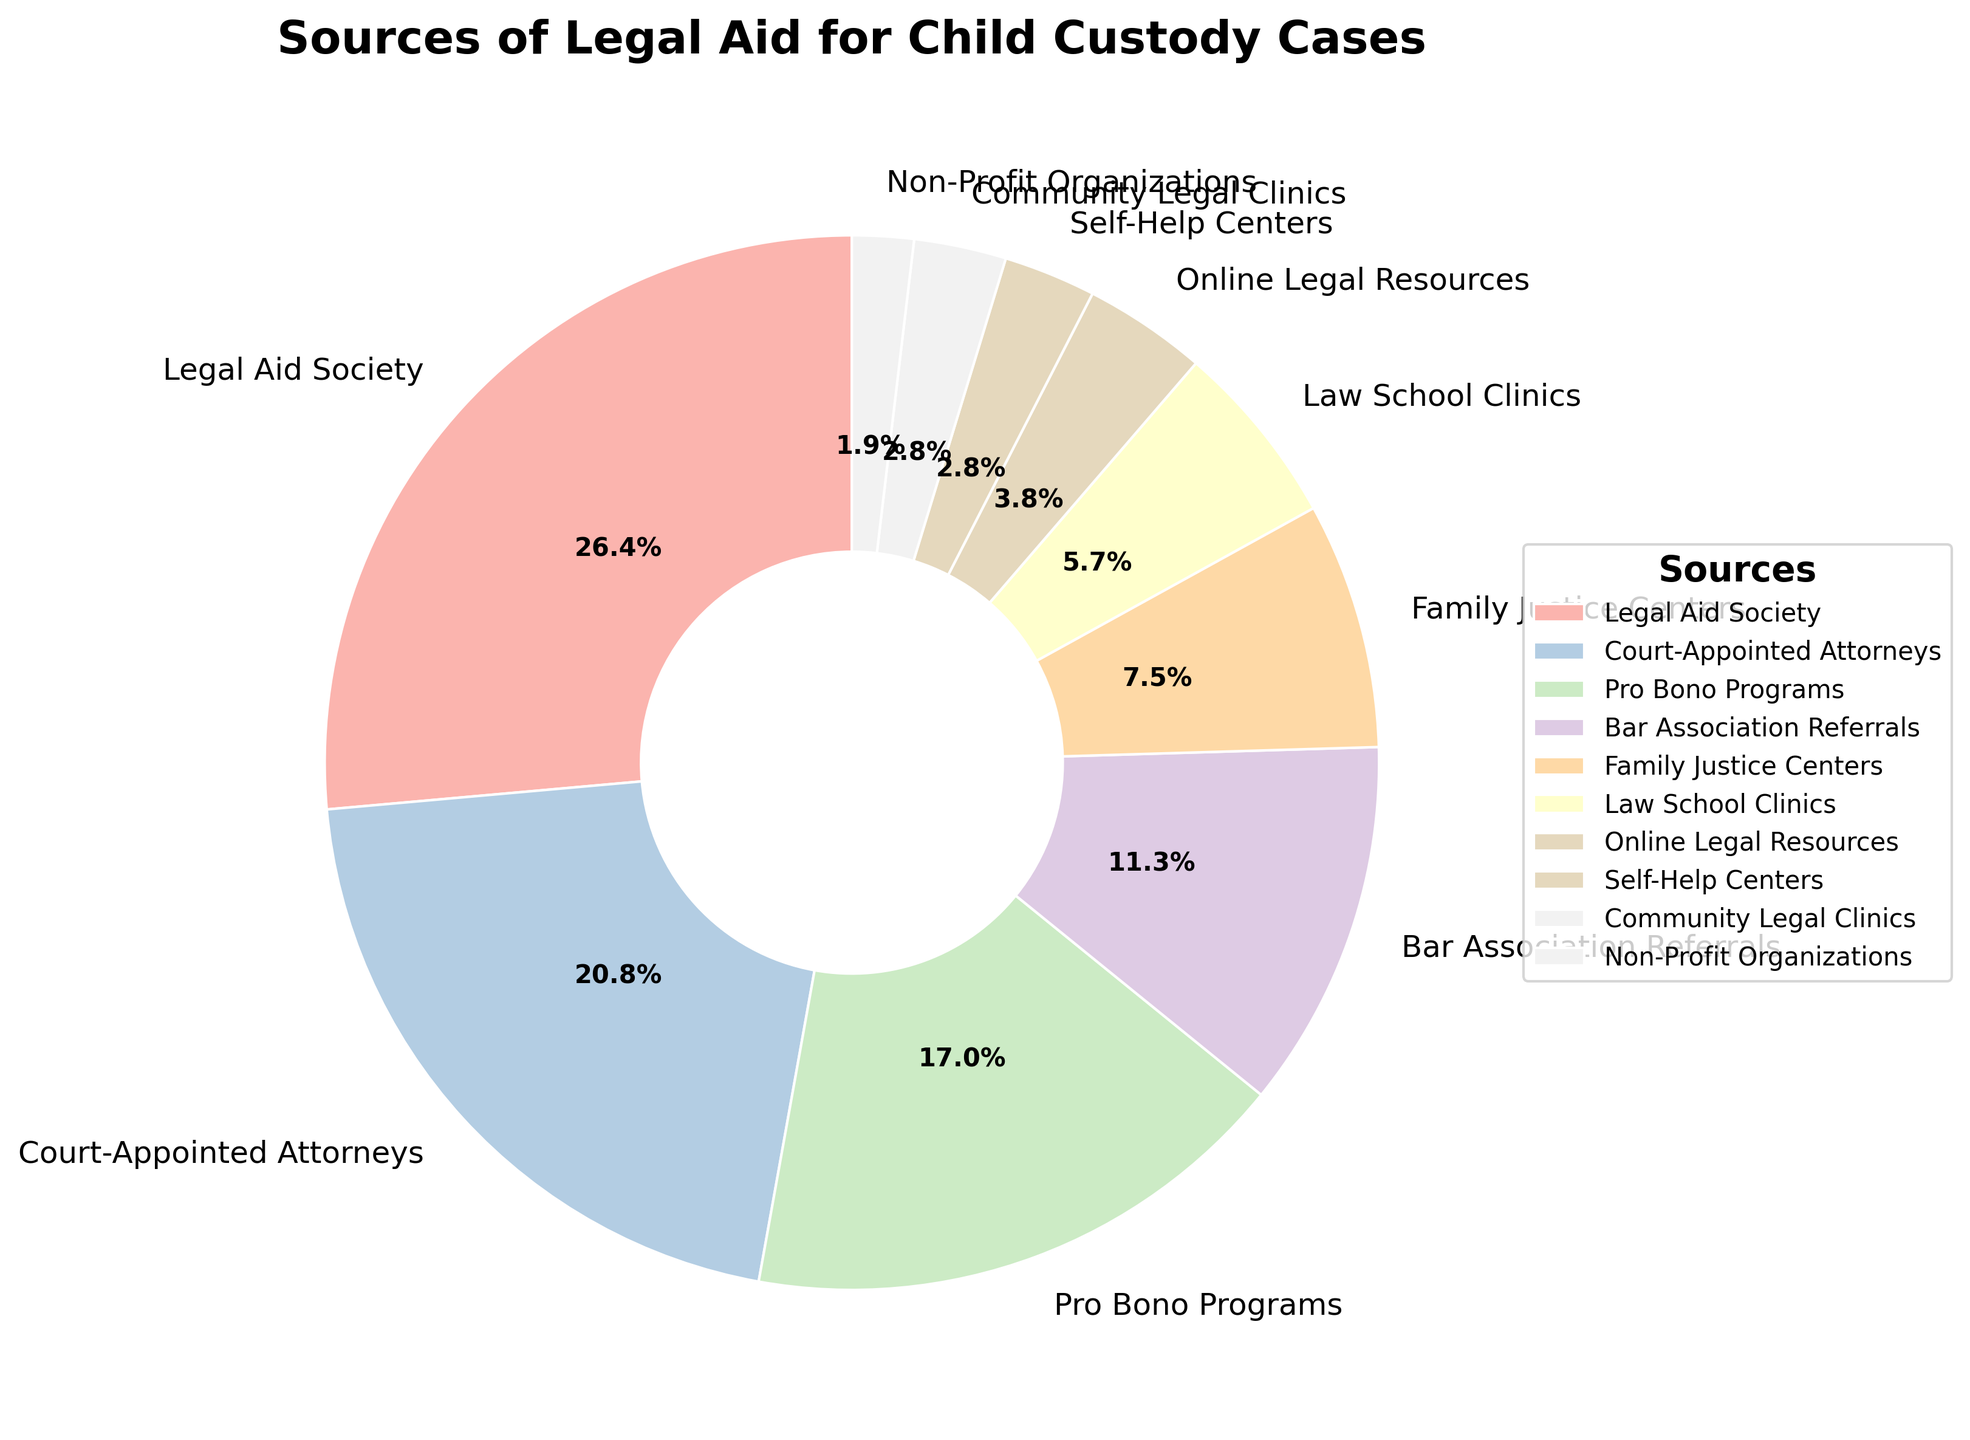Which source of legal aid provides the largest percentage? The source with the largest percentage can be determined by identifying the section with the highest value. The largest portion is the "Legal Aid Society" with 28%.
Answer: Legal Aid Society How much more does the Legal Aid Society provide compared to Online Legal Resources? To determine the difference, subtract the percentage of Online Legal Resources from the Legal Aid Society. 28% - 4% = 24%.
Answer: 24% Which two sources provide the same percentage of legal aid? By checking all percentages, we can see that Self-Help Centers and Community Legal Clinics both provide 3%.
Answer: Self-Help Centers and Community Legal Clinics What is the combined percentage of legal aid provided by Family Justice Centers and Law School Clinics? Add the percentages for Family Justice Centers (8%) and Law School Clinics (6%). 8% + 6% = 14%.
Answer: 14% Which source of legal aid has the smallest percentage? The source with the smallest percentage is identified by the smallest section. "Non-Profit Organizations" has the smallest percentage at 2%.
Answer: Non-Profit Organizations Is the percentage of aid provided by Court-Appointed Attorneys greater than that of Pro Bono Programs? Compare the percentages for Court-Appointed Attorneys (22%) and Pro Bono Programs (18%). 22% is greater than 18%.
Answer: Yes What percentage of legal aid is provided by sources other than Legal Aid Society, Court-Appointed Attorneys, and Pro Bono Programs? Subtract the percentages of these three sources from 100%. 100% - (28% + 22% + 18%) = 32%.
Answer: 32% What is the difference in the percentage of legal aid provided by Bar Association Referrals and Community Legal Clinics? Subtract the percentage of Community Legal Clinics from Bar Association Referrals. 12% - 3% = 9%.
Answer: 9% What is the combined contribution of the three smallest sources of legal aid? Add the percentages for Non-Profit Organizations (2%), Community Legal Clinics (3%), and Self-Help Centers (3%). 2% + 3% + 3% = 8%.
Answer: 8% If the percentage of legal aid from Online Legal Resources doubled, what would be its new percentage? Double the percentage for Online Legal Resources. 4% * 2 = 8%.
Answer: 8% 